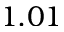Convert formula to latex. <formula><loc_0><loc_0><loc_500><loc_500>1 . 0 1</formula> 